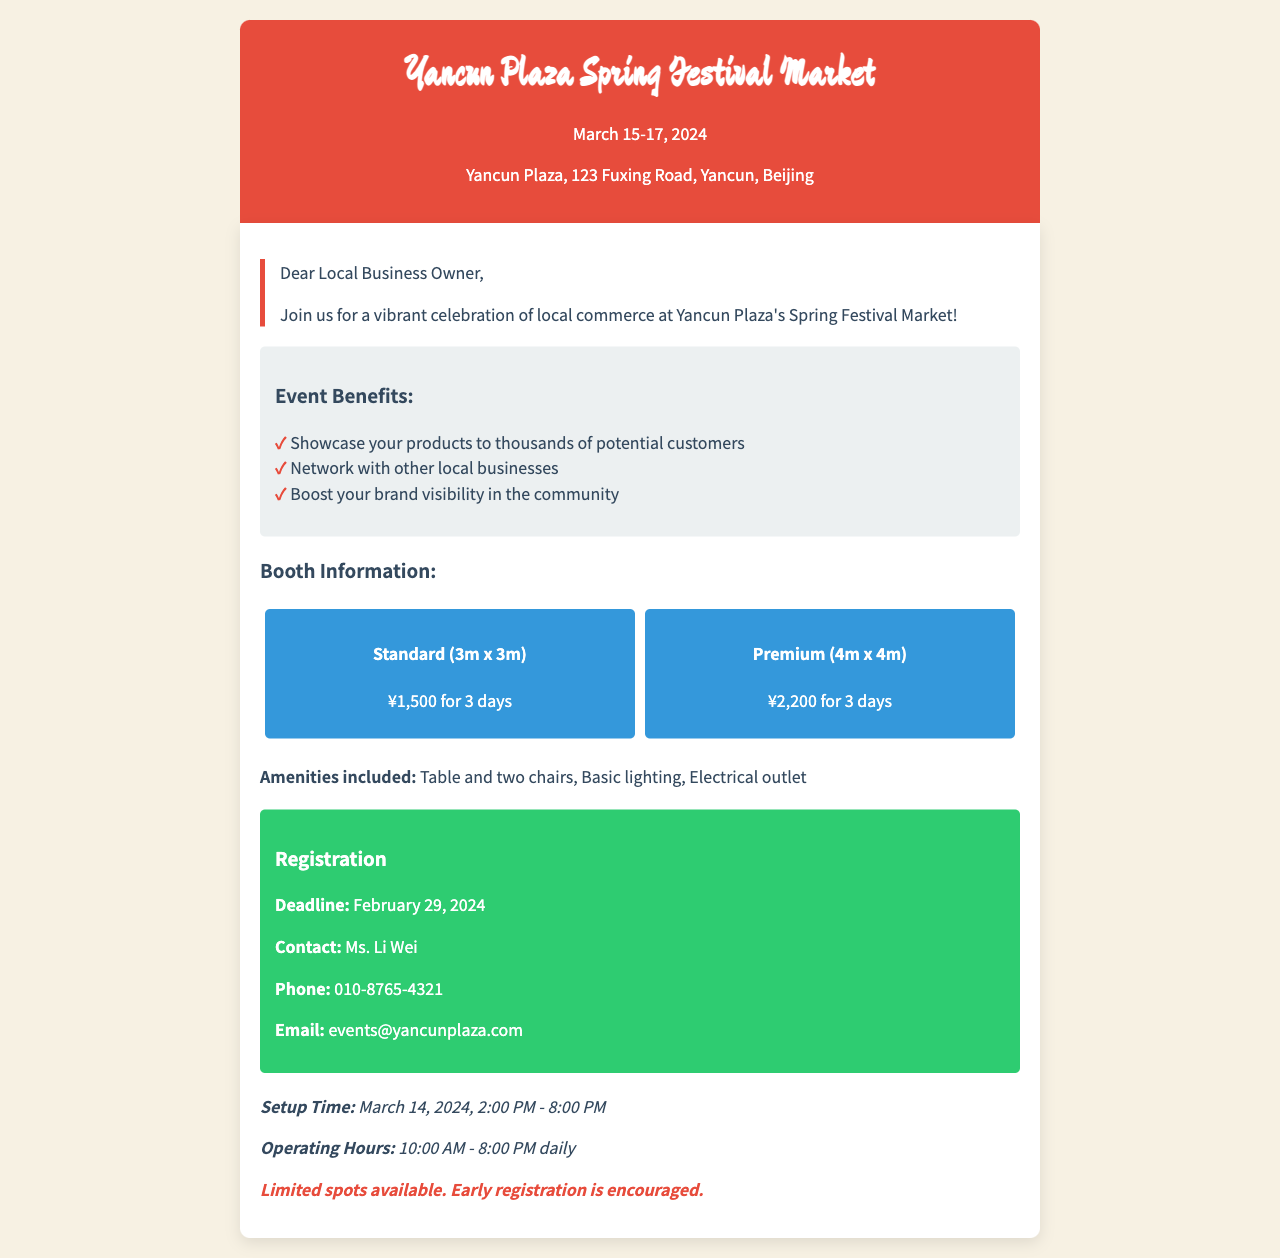What are the event dates? The document specifies the event dates as March 15-17, 2024.
Answer: March 15-17, 2024 What is the location of the event? The document mentions the event location as Yancun Plaza, 123 Fuxing Road, Yancun, Beijing.
Answer: Yancun Plaza, 123 Fuxing Road, Yancun, Beijing What is the price for the Standard booth? The document states that the price for the Standard booth (3m x 3m) is ¥1,500 for 3 days.
Answer: ¥1,500 for 3 days Who should be contacted for registration? The document lists Ms. Li Wei as the contact person for registration.
Answer: Ms. Li Wei What is the registration deadline? The registration deadline mentioned in the document is February 29, 2024.
Answer: February 29, 2024 What amenities are included with the booth rental? The document lists table and two chairs, basic lighting, and electrical outlet as included amenities.
Answer: Table and two chairs, Basic lighting, Electrical outlet How long is the setup time? The document specifies the setup time as March 14, 2024, from 2:00 PM to 8:00 PM.
Answer: March 14, 2024, 2:00 PM - 8:00 PM What are the operating hours of the event? The document states that the operating hours are 10:00 AM - 8:00 PM daily.
Answer: 10:00 AM - 8:00 PM daily How many booth sizes are offered? The document mentions two booth sizes: Standard and Premium.
Answer: Two 